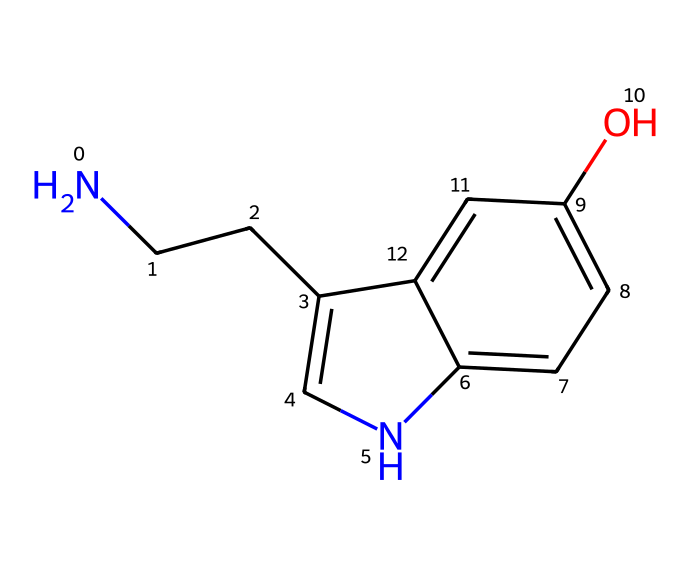What is the molecular formula of serotonin? In interpreting the SMILES representation, we can identify the atoms present: nitrogen (N), carbon (C), and oxygen (O). Counting those, we determine the molecular formula is C10H12N2O.
Answer: C10H12N2O How many rings are present in this structure? By examining the chemical structure indicated by the SMILES, we can see that there are two interconnected rings in the bicyclic system.
Answer: 2 Does serotonin exhibit geometric isomerism? The presence of a carbon-carbon double bond or constraints in the molecular structure that could allow for different spatial arrangements would enable geometric isomerism. Here, we notice no such double bonds or relevant stereocenters that would create geometric isomers.
Answer: No What functional groups are present in serotonin? In the chemical structure, we can see a hydroxyl group (–OH) indicated by the "O" attached to the carbon ring, and an amine group (–NH2) stemming from the nitrogen atom. Thus, the functional groups are hydroxyl and amine.
Answer: Hydroxyl and amine How many total carbon atoms are in serotonin's structure? Counting the carbon atoms in the provided SMILES representation, we can identify that there are a total of 10 carbon atoms throughout the associated structure.
Answer: 10 What is the significance of the nitrogen atom in this structure? The nitrogen atom in serotonin is critical as it is part of the amine functional group, contributing to the molecule's role as a neurotransmitter and influencing mood and psychological behavior.
Answer: Neurotransmitter role 